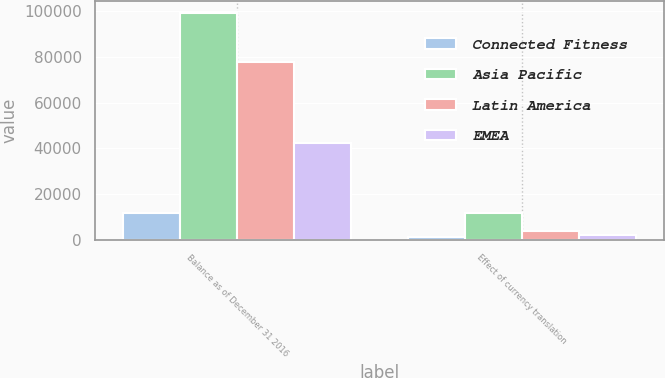Convert chart. <chart><loc_0><loc_0><loc_500><loc_500><stacked_bar_chart><ecel><fcel>Balance as of December 31 2016<fcel>Effect of currency translation<nl><fcel>Connected Fitness<fcel>11910<fcel>1132<nl><fcel>Asia Pacific<fcel>99245<fcel>11910<nl><fcel>Latin America<fcel>77586<fcel>3737<nl><fcel>EMEA<fcel>42436<fcel>2305<nl></chart> 